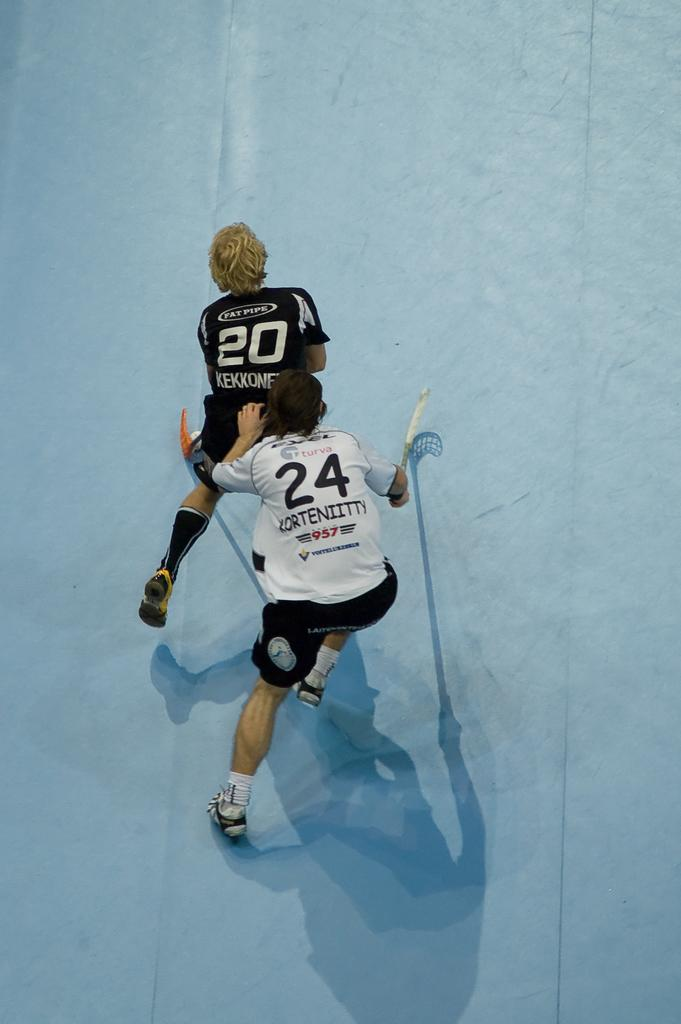<image>
Create a compact narrative representing the image presented. Two hockey players standing behind one another, 20 in front 24 in back 